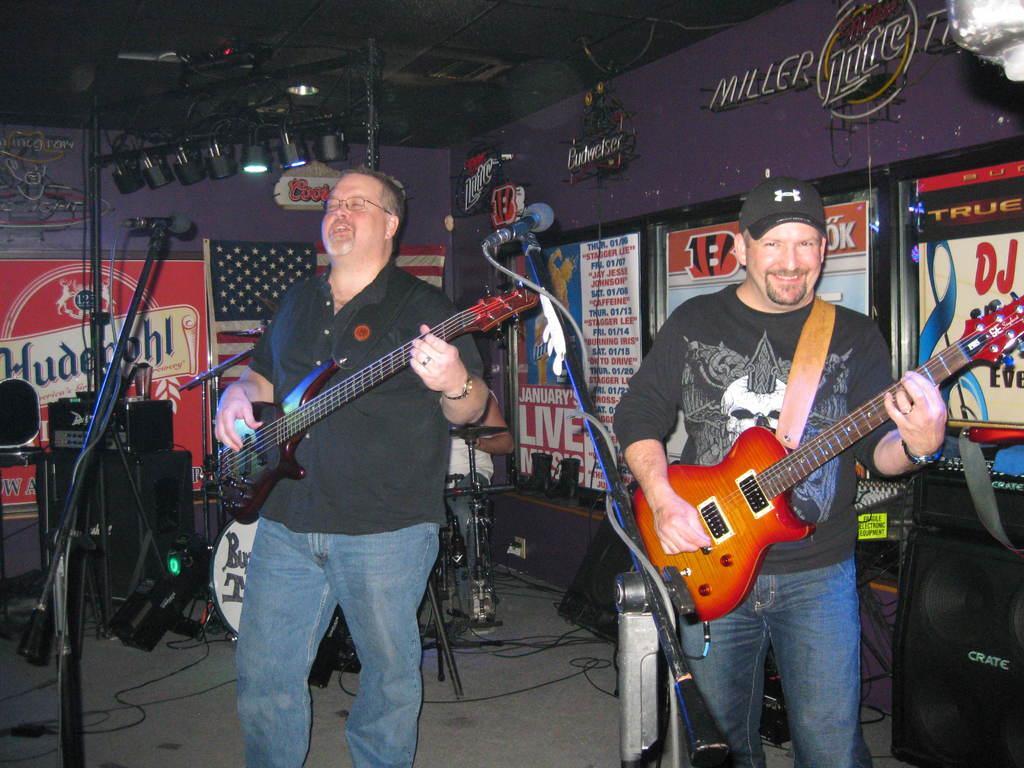Please provide a concise description of this image. In this picture there are two men playing guitar. There is a mic and a light. There are few posters on the wall. 